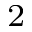Convert formula to latex. <formula><loc_0><loc_0><loc_500><loc_500>_ { 2 }</formula> 